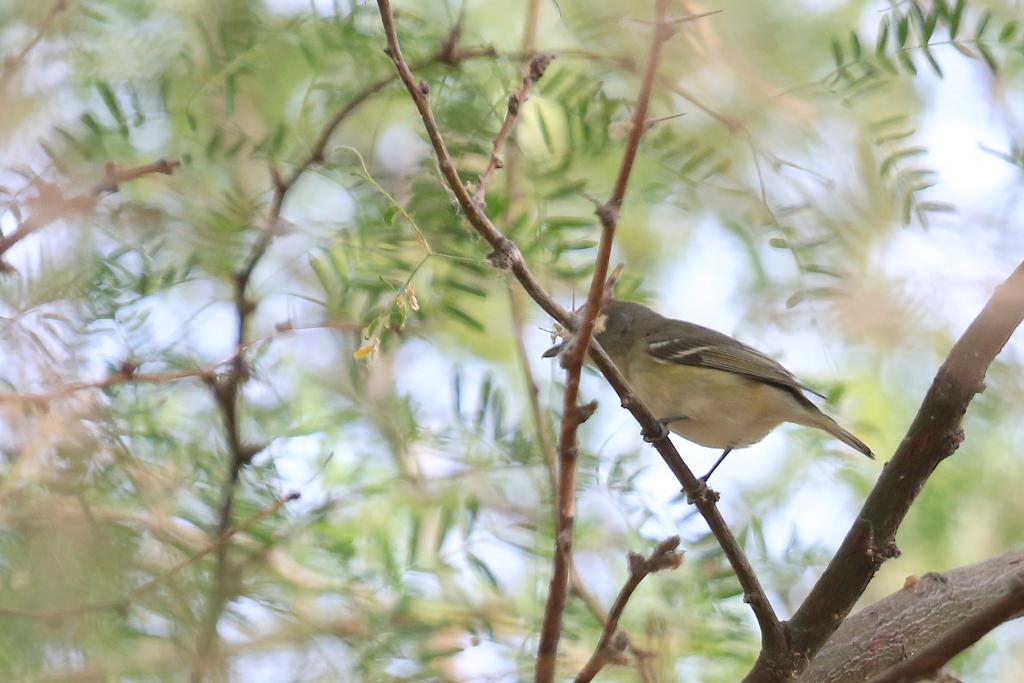In one or two sentences, can you explain what this image depicts? In this image I can see a bird visible on the tree and back side of the tree I can see the sky. 